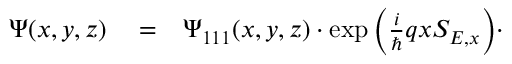Convert formula to latex. <formula><loc_0><loc_0><loc_500><loc_500>\begin{array} { r l r } { \Psi ( x , y , z ) } & = } & { \Psi _ { 1 1 1 } ( x , y , z ) \cdot \exp { \left ( \frac { i } { } q x S _ { E , x } \right ) } \cdot } \end{array}</formula> 